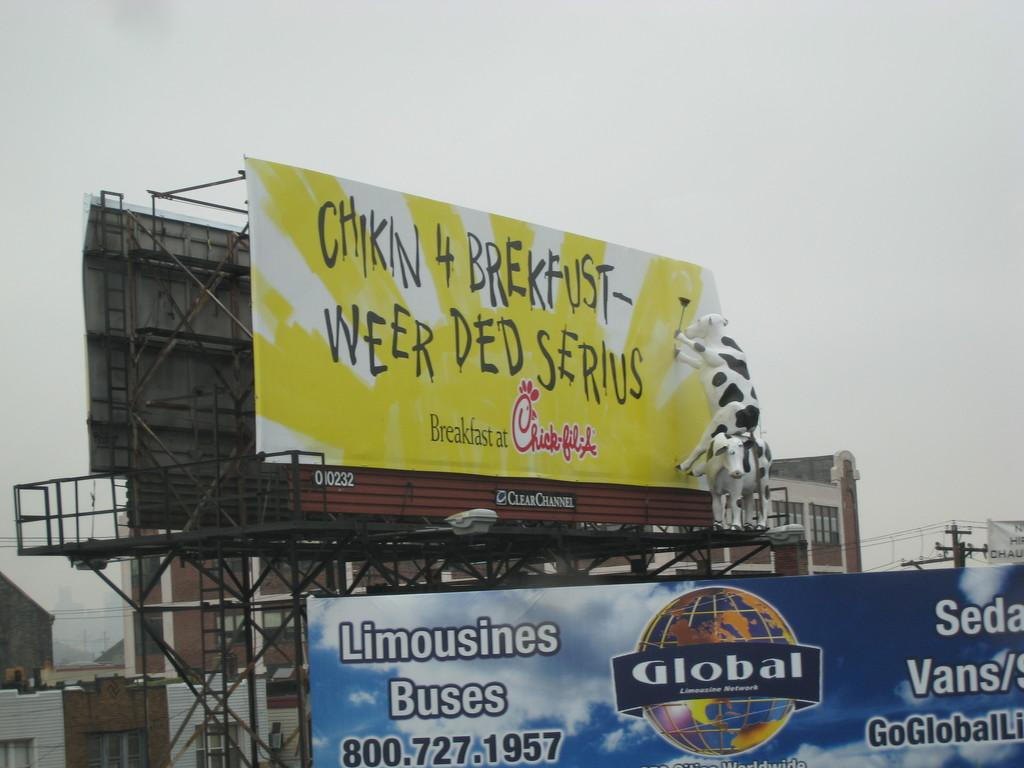Provide a one-sentence caption for the provided image. Chick-fil-a advertise on a billboard on the road for breakfast. 